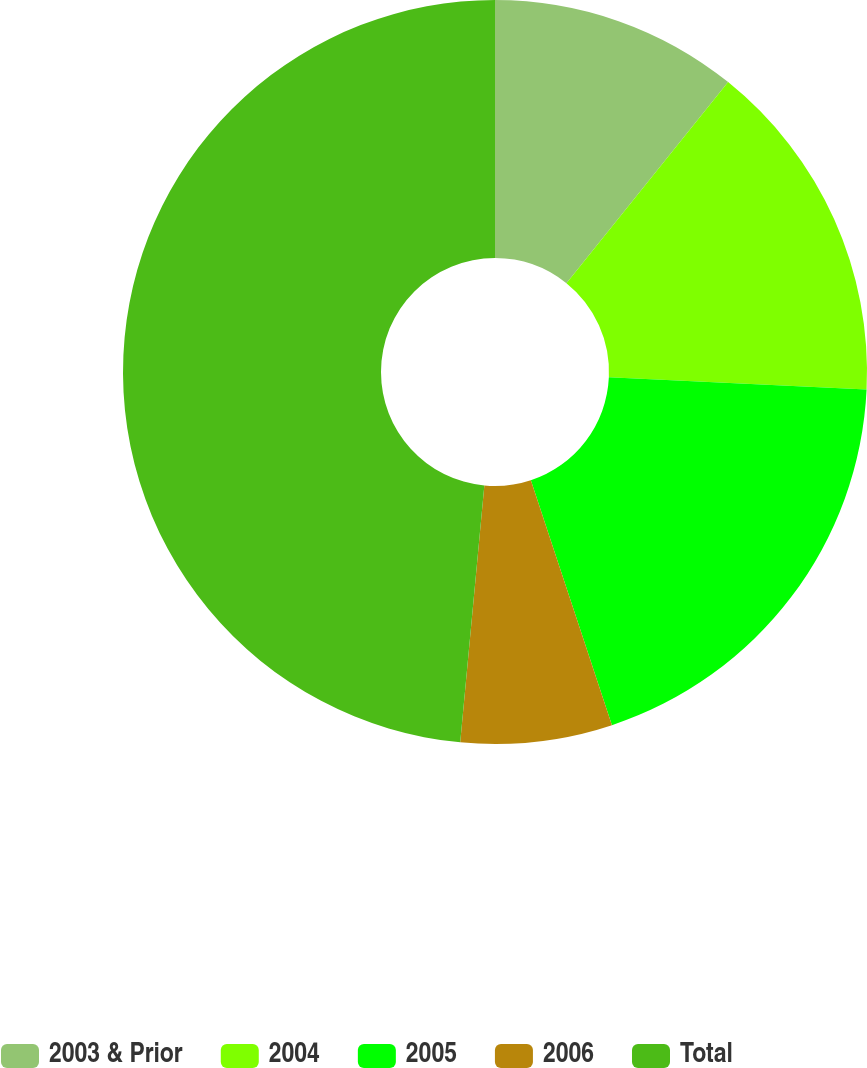Convert chart. <chart><loc_0><loc_0><loc_500><loc_500><pie_chart><fcel>2003 & Prior<fcel>2004<fcel>2005<fcel>2006<fcel>Total<nl><fcel>10.78%<fcel>14.97%<fcel>19.16%<fcel>6.58%<fcel>48.51%<nl></chart> 